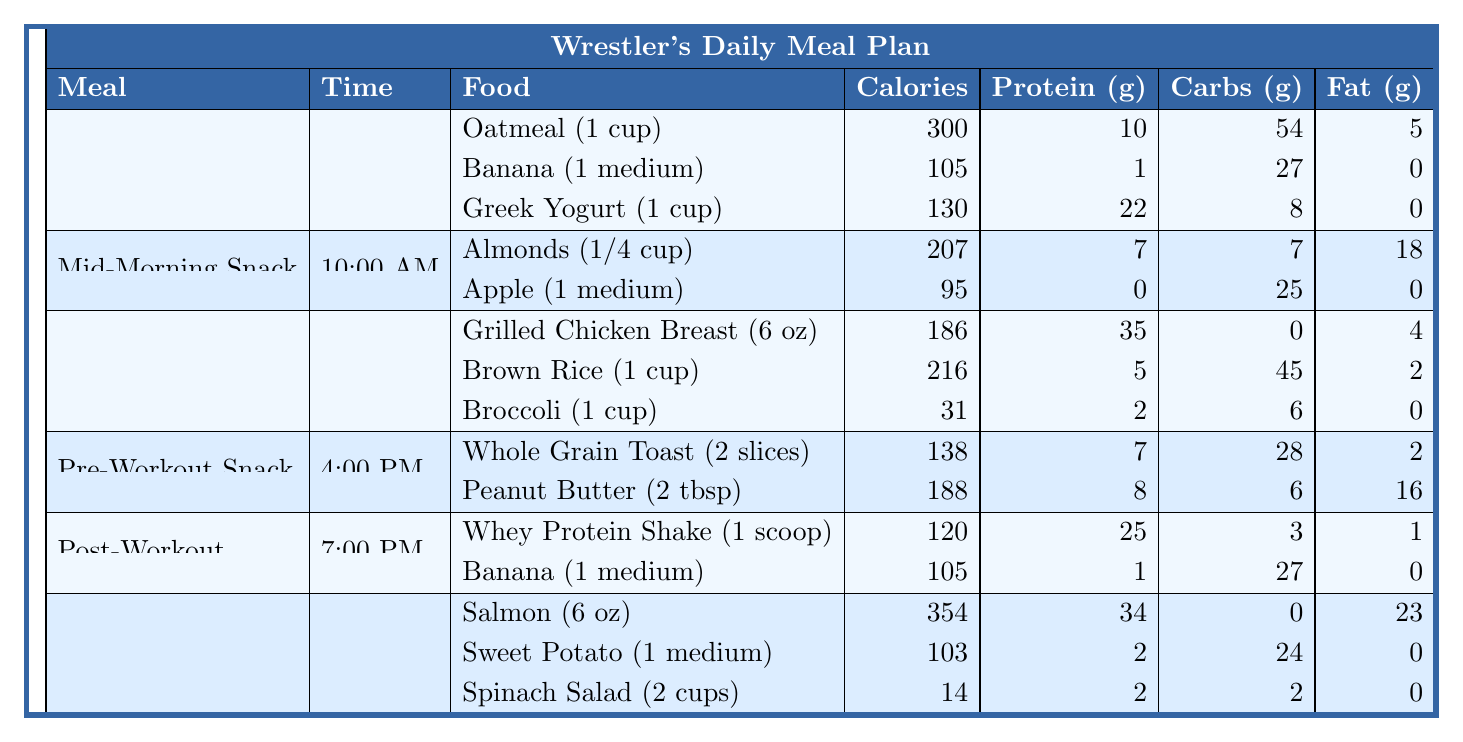What is the total calorie count for the breakfast meal? To find the total calorie count for breakfast, I will add the calories from each item listed under breakfast: Oatmeal (300 calories) + Banana (105 calories) + Greek Yogurt (130 calories) = 535 calories total.
Answer: 535 calories Which meal contains the highest amount of protein? I will look at the protein content for each meal. The breakfast meal has a total of 33g (10g + 1g + 22g), the mid-morning snack has 7g, lunch has a total of 42g (35g + 5g + 2g), the pre-workout snack has 15g (7g + 8g), the post-workout has 26g (25g + 1g), and dinner has 38g (34g + 2g + 2g). The meal with the highest protein is lunch with 42g.
Answer: Lunch What is the total fat content in the mid-morning snack? The mid-morning snack includes Almonds (18g of fat) and Apple (0g of fat). Adding these together gives a total of 18g of fat for this snack.
Answer: 18g Is there any meal that contains zero carbohydrates? Yes, I will check each meal's carbohydrate content. The grilled chicken breast in lunch has 0g of carbohydrates. Therefore, lunch contains an item with zero carbohydrates.
Answer: Yes What is the average protein content per meal? To find the average protein content, I will first add up all protein for each meal: Breakfast = 33g, Mid-Morning Snack = 7g, Lunch = 42g, Pre-Workout = 15g, Post-Workout = 26g, Dinner = 38g. This sums up to 161g of protein. There are 6 meals, so I divide 161g by 6, which equals approximately 26.83g.
Answer: Approximately 26.83g How many total calories do the snacks provide compared to lunch? First, I will calculate calories from snacks: Mid-Morning Snack (302 calories) + Pre-Workout Snack (326 calories) = 628 calories. Lunch has 431 calories. The difference between snacks and lunch (628 - 431) is 197 calories more in snacks.
Answer: Snacks provide 197 calories more than lunch What is the total amount of carbohydrates consumed for the entire day? I will sum the carbohydrates for each meal: Breakfast (54g + 27g + 8g) = 89g, Mid-Morning Snack (7g + 25g) = 32g, Lunch (0g + 45g + 6g) = 51g, Pre-Workout Snack (28g + 6g) = 34g, Post-Workout (3g + 27g) = 30g, Dinner (0g + 24g + 2g) = 26g. The total of all carbohydrates is 89g + 32g + 51g + 34g + 30g + 26g = 262g.
Answer: 262g Which meal comes closest to providing 200 calories? I will check each meal's calorie count. The closest to 200 calories is the pre-workout snack with 326 calories and does not exceed 200 calories. The best candidate below 200 is the mid-morning snack with 302 calories but not close enough.
Answer: Mid-Morning Snack with 207 calories Is there more protein in the post-workout meal than in the dinner? The post-workout meal has a total of 26g (25g + 1g), while dinner has a total of 38g (34g + 2g + 2g). Thus, the post-workout meal does not have more protein than dinner.
Answer: No What is the difference in fat content between the dinner and breakfast meals? The total fat content for dinner is 23g and for breakfast is 5g. To find the difference, I subtract the two: 23g (dinner) - 5g (breakfast) = 18g more fat in dinner.
Answer: 18g more fat in dinner 